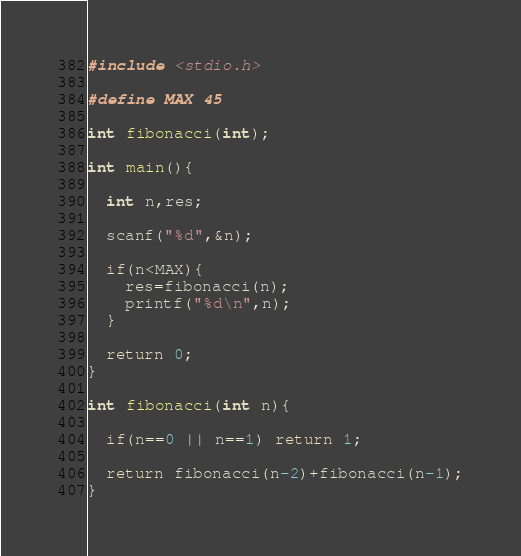<code> <loc_0><loc_0><loc_500><loc_500><_C_>#include <stdio.h>

#define MAX 45

int fibonacci(int);

int main(){

  int n,res;

  scanf("%d",&n);

  if(n<MAX){
    res=fibonacci(n);
    printf("%d\n",n);
  }

  return 0;
}

int fibonacci(int n){

  if(n==0 || n==1) return 1;

  return fibonacci(n-2)+fibonacci(n-1);
}</code> 